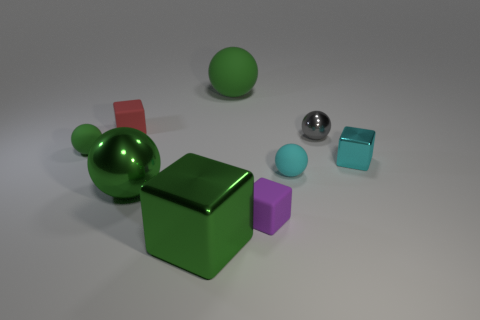There is a rubber cube that is in front of the green ball that is in front of the tiny sphere that is left of the red matte thing; what color is it?
Your answer should be very brief. Purple. Do the tiny ball in front of the tiny metallic cube and the green block have the same material?
Provide a succinct answer. No. Are there any tiny matte balls that have the same color as the large metal block?
Offer a very short reply. Yes. Are there any cyan rubber spheres?
Your answer should be compact. Yes. Is the size of the cyan metal cube right of the cyan rubber ball the same as the small gray metallic object?
Provide a succinct answer. Yes. Is the number of small gray spheres less than the number of tiny yellow matte things?
Provide a succinct answer. No. The big shiny thing that is on the left side of the metallic block left of the small metallic thing in front of the gray sphere is what shape?
Keep it short and to the point. Sphere. Is there a small brown cylinder made of the same material as the small green object?
Your answer should be very brief. No. There is a metal ball to the right of the tiny cyan sphere; does it have the same color as the small thing that is behind the gray metallic sphere?
Ensure brevity in your answer.  No. Is the number of metal cubes that are in front of the red block less than the number of cyan shiny objects?
Ensure brevity in your answer.  No. 